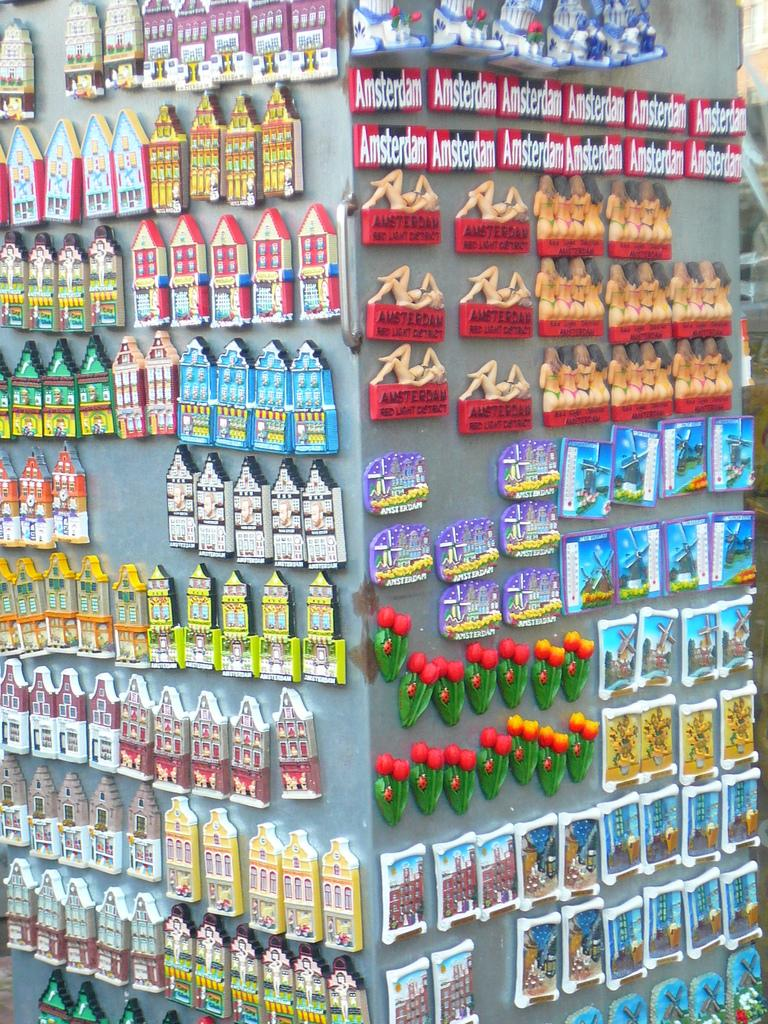Provide a one-sentence caption for the provided image. Two rows of Amsterdam magnets are above rows of maked women magnets. 